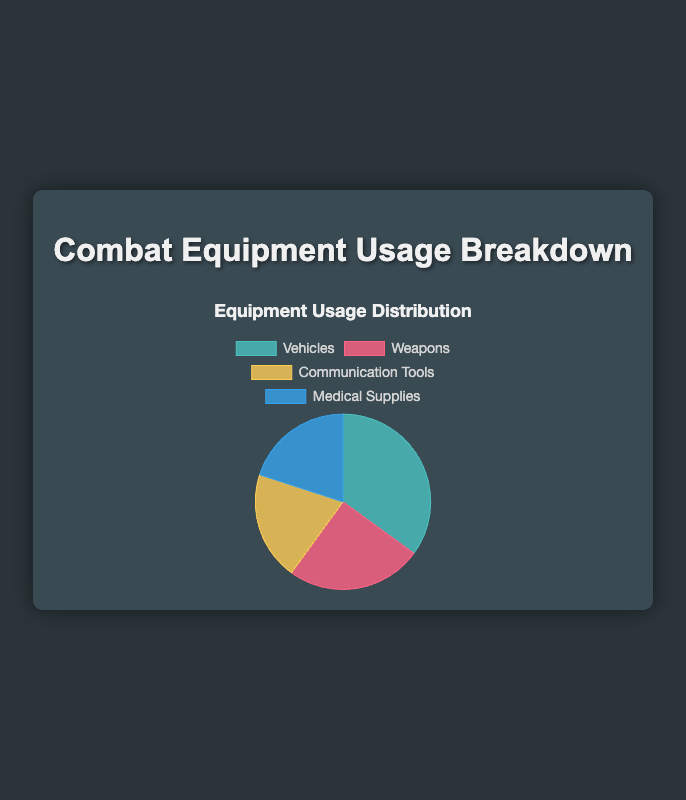What is the largest category of equipment usage? From the pie chart, the 'Vehicles' slice is the largest among all categories, occupying 35% of the total equipment usage. This can be visually identified as the largest piece in the pie chart.
Answer: Vehicles Which two categories of equipment usage have the same percentage? By looking at the pie chart, both 'Communication Tools' and 'Medical Supplies' slices are of the same size and are labeled with 20% usage each.
Answer: Communication Tools and Medical Supplies How much more usage do vehicles have compared to weapons? The pie chart shows that vehicles have 35% usage while weapons have 25%. The difference is 35% - 25% = 10%.
Answer: 10% If we combine the usage percentages of communication tools and medical supplies, how much is it? From the pie chart, 'Communication Tools' and 'Medical Supplies' each have 20% usage. Adding them together: 20% + 20% = 40%.
Answer: 40% Which category has the least equipment usage? By examining the pie chart, 'Weapons' has 25% usage, which is less than vehicles' 35% but more than 'Communication Tools' and 'Medical Supplies' which each have 20%. Thus, 'Communication Tools' and 'Medical Supplies' share the least usage percentages.
Answer: Communication Tools and Medical Supplies Which color is used to represent the 'Weapons' category in the pie chart? By referring to the visual information, the 'Weapons' category is depicted in the pie chart using the red-colored slice.
Answer: Red Is the combined usage of weapons and medical supplies greater or less than that of vehicles? The pie chart indicates that weapons have 25% and medical supplies have 20% usage. Combined usage is 25% + 20% = 45%. Vehicles have 35% usage, so the combined usage of weapons and medical supplies (45%) is greater than that of vehicles (35%).
Answer: Greater What percentage of equipment usage is not attributed to vehicles? Vehicles account for 35% of the usage. The remaining percentage is 100% - 35% = 65%.
Answer: 65% What are the colors used to represent each category of equipment in the pie chart? The pie chart represents 'Vehicles' in green, 'Weapons' in red, 'Communication Tools' in yellow, and 'Medical Supplies' in blue.
Answer: Green, Red, Yellow, Blue Which two categories together make up more than half of the total equipment usage? Referring to the pie chart, the categories are 'Vehicles' at 35% and 'Weapons' at 25%. Together, their total is 35% + 25% = 60%, which is more than half of 100%.
Answer: Vehicles and Weapons 